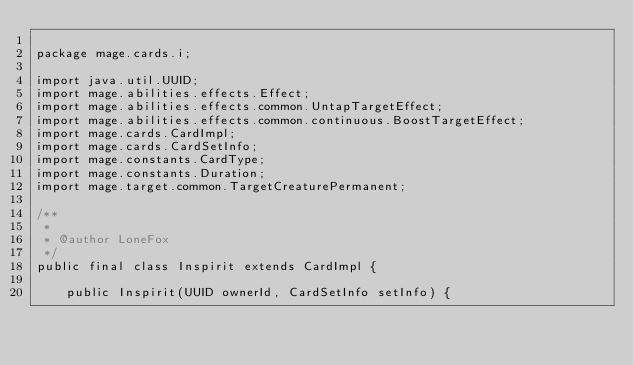Convert code to text. <code><loc_0><loc_0><loc_500><loc_500><_Java_>
package mage.cards.i;

import java.util.UUID;
import mage.abilities.effects.Effect;
import mage.abilities.effects.common.UntapTargetEffect;
import mage.abilities.effects.common.continuous.BoostTargetEffect;
import mage.cards.CardImpl;
import mage.cards.CardSetInfo;
import mage.constants.CardType;
import mage.constants.Duration;
import mage.target.common.TargetCreaturePermanent;

/**
 *
 * @author LoneFox
 */
public final class Inspirit extends CardImpl {

    public Inspirit(UUID ownerId, CardSetInfo setInfo) {</code> 